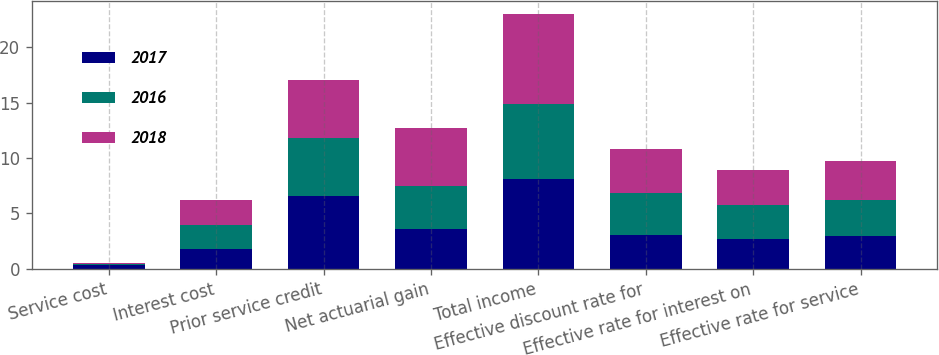<chart> <loc_0><loc_0><loc_500><loc_500><stacked_bar_chart><ecel><fcel>Service cost<fcel>Interest cost<fcel>Prior service credit<fcel>Net actuarial gain<fcel>Total income<fcel>Effective discount rate for<fcel>Effective rate for interest on<fcel>Effective rate for service<nl><fcel>2017<fcel>0.3<fcel>1.8<fcel>6.6<fcel>3.6<fcel>8.1<fcel>3.09<fcel>2.71<fcel>2.98<nl><fcel>2016<fcel>0.1<fcel>2.2<fcel>5.2<fcel>3.9<fcel>6.8<fcel>3.76<fcel>3.07<fcel>3.25<nl><fcel>2018<fcel>0.1<fcel>2.2<fcel>5.2<fcel>5.2<fcel>8.1<fcel>3.97<fcel>3.1<fcel>3.46<nl></chart> 